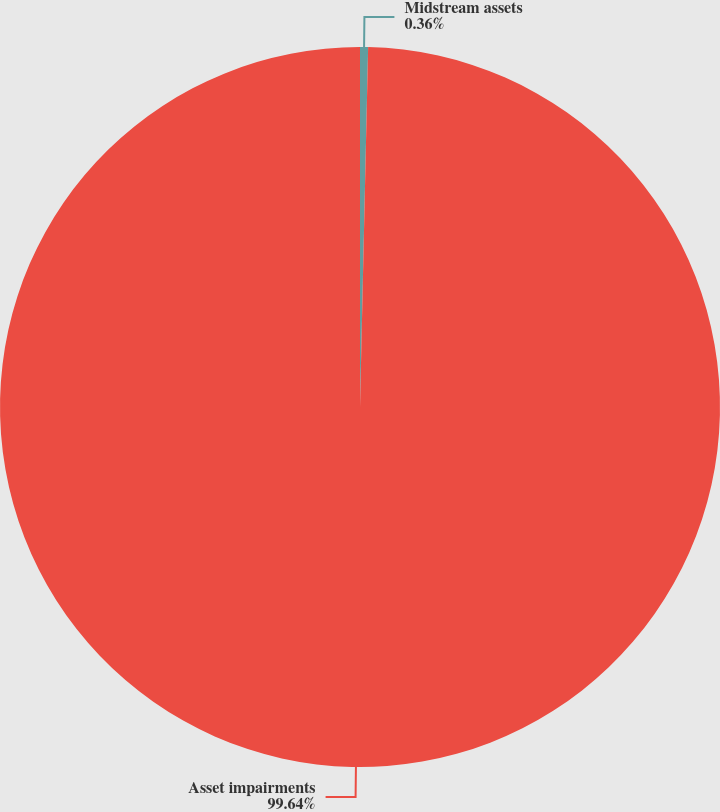<chart> <loc_0><loc_0><loc_500><loc_500><pie_chart><fcel>Midstream assets<fcel>Asset impairments<nl><fcel>0.36%<fcel>99.64%<nl></chart> 